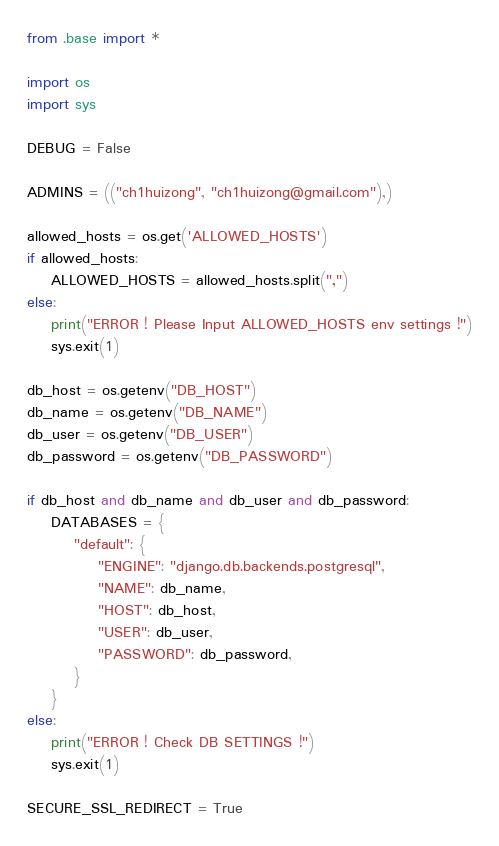<code> <loc_0><loc_0><loc_500><loc_500><_Python_>from .base import *

import os
import sys

DEBUG = False

ADMINS = (("ch1huizong", "ch1huizong@gmail.com"),)

allowed_hosts = os.get('ALLOWED_HOSTS')
if allowed_hosts:
    ALLOWED_HOSTS = allowed_hosts.split(",")
else:
    print("ERROR ! Please Input ALLOWED_HOSTS env settings !")
    sys.exit(1)

db_host = os.getenv("DB_HOST")
db_name = os.getenv("DB_NAME")
db_user = os.getenv("DB_USER")
db_password = os.getenv("DB_PASSWORD")

if db_host and db_name and db_user and db_password:
    DATABASES = {
        "default": {
            "ENGINE": "django.db.backends.postgresql",
            "NAME": db_name,
            "HOST": db_host,
            "USER": db_user,
            "PASSWORD": db_password,
        }
    }
else:
    print("ERROR ! Check DB SETTINGS !")
    sys.exit(1)

SECURE_SSL_REDIRECT = True</code> 